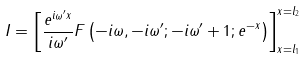<formula> <loc_0><loc_0><loc_500><loc_500>I = \left [ \frac { e ^ { i \omega ^ { \prime } x } } { i \omega ^ { \prime } } F \left ( - i \omega , - i \omega ^ { \prime } ; - i \omega ^ { \prime } + 1 ; e ^ { - x } \right ) \right ] _ { x = l _ { 1 } } ^ { x = l _ { 2 } }</formula> 